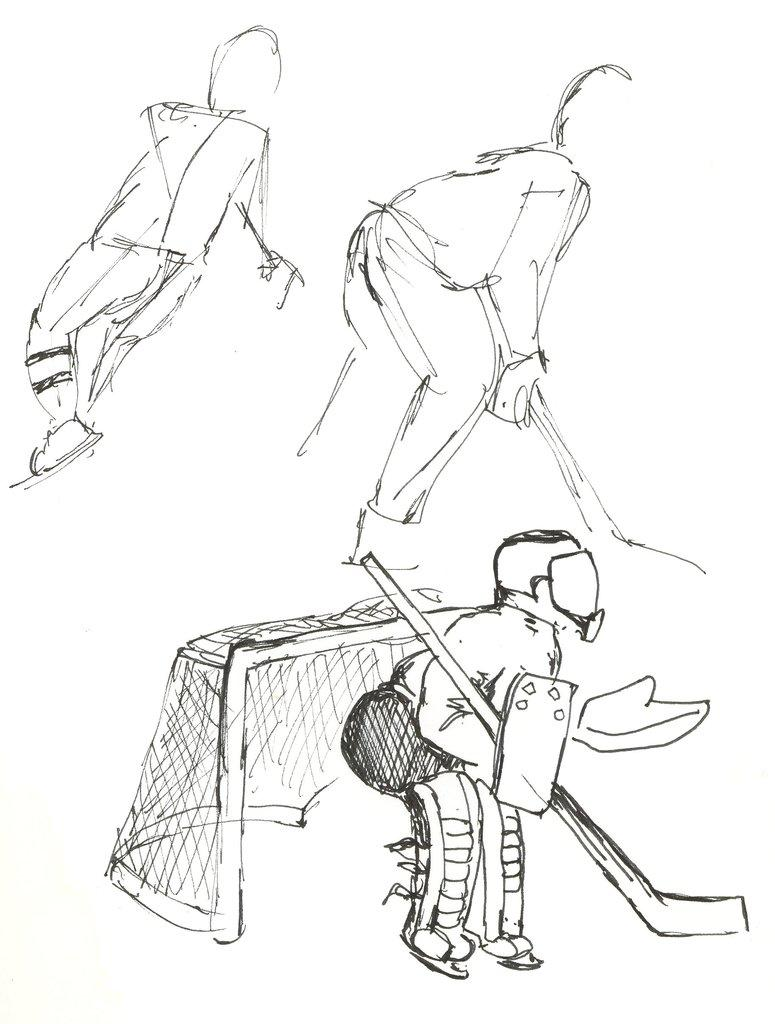How many people are in the image? There are three persons in the image. What are the persons holding in the image? Each person is holding a hockey stick. What can be seen in the image besides the people and hockey sticks? There is one net in the image. What is the color of the background in the image? The background of the image is white. What letters are visible on the hockey sticks in the image? There are no letters visible on the hockey sticks in the image. Can you see any actors in the image? There are no actors present in the image. 